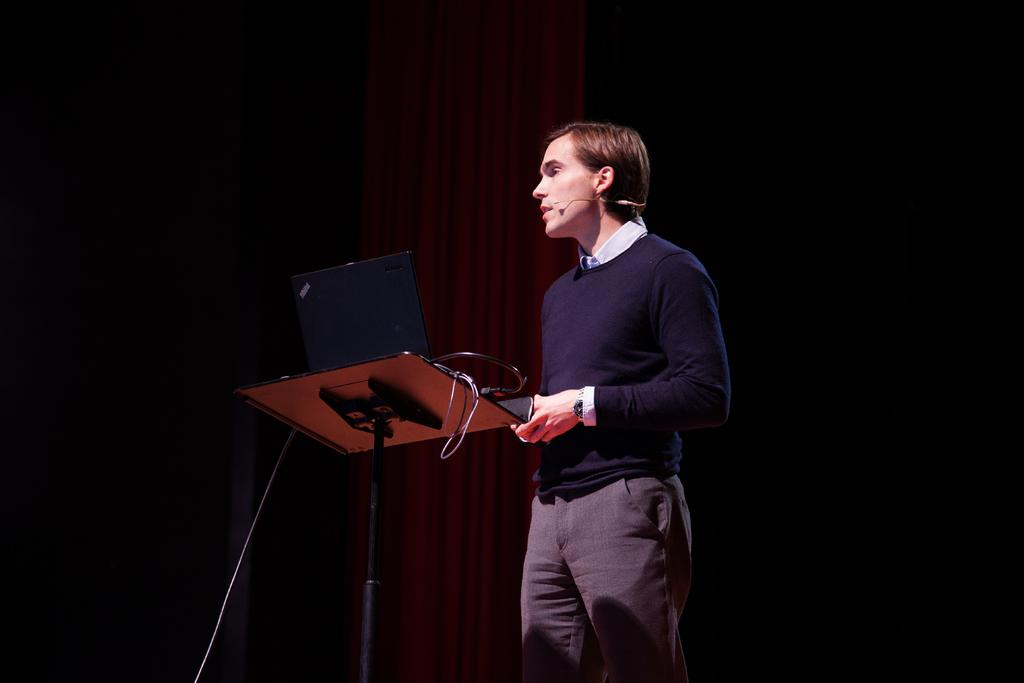Who is present in the image? There is a man in the image. What is the man wearing? The man is wearing a blue jacket. What type of object can be seen in the image besides the man? There is an electrical equipment in the image. What type of poison is the man holding in the image? There is no poison present in the image; the man is wearing a blue jacket and there is an electrical equipment in the image. Is the man playing basketball in the image? There is no basketball or indication of the man playing basketball in the image. 